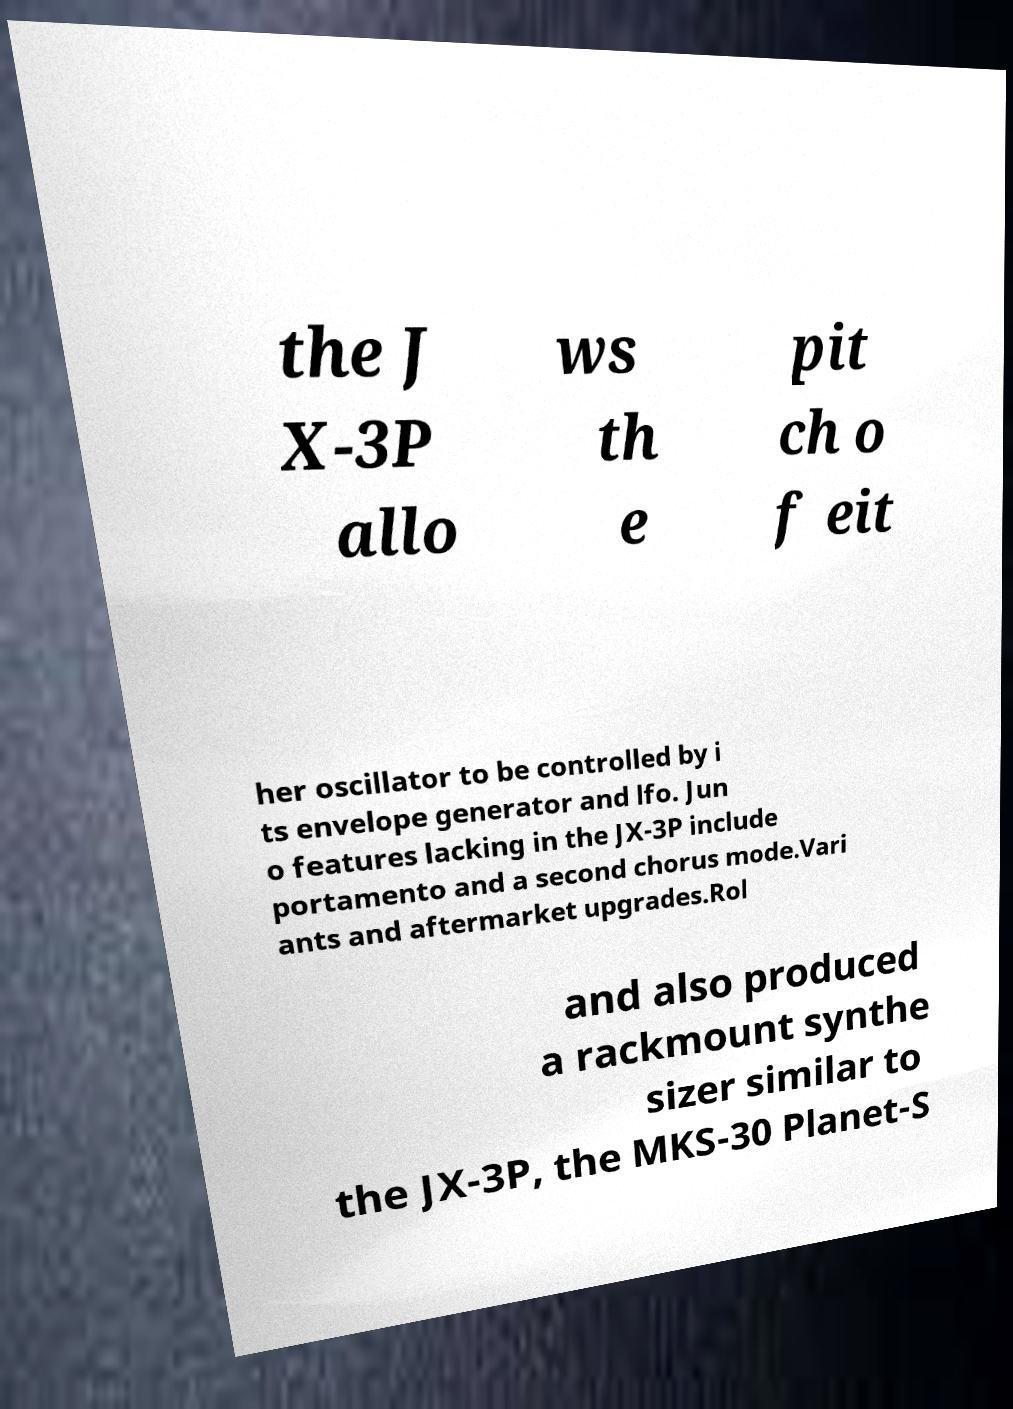Could you extract and type out the text from this image? the J X-3P allo ws th e pit ch o f eit her oscillator to be controlled by i ts envelope generator and lfo. Jun o features lacking in the JX-3P include portamento and a second chorus mode.Vari ants and aftermarket upgrades.Rol and also produced a rackmount synthe sizer similar to the JX-3P, the MKS-30 Planet-S 